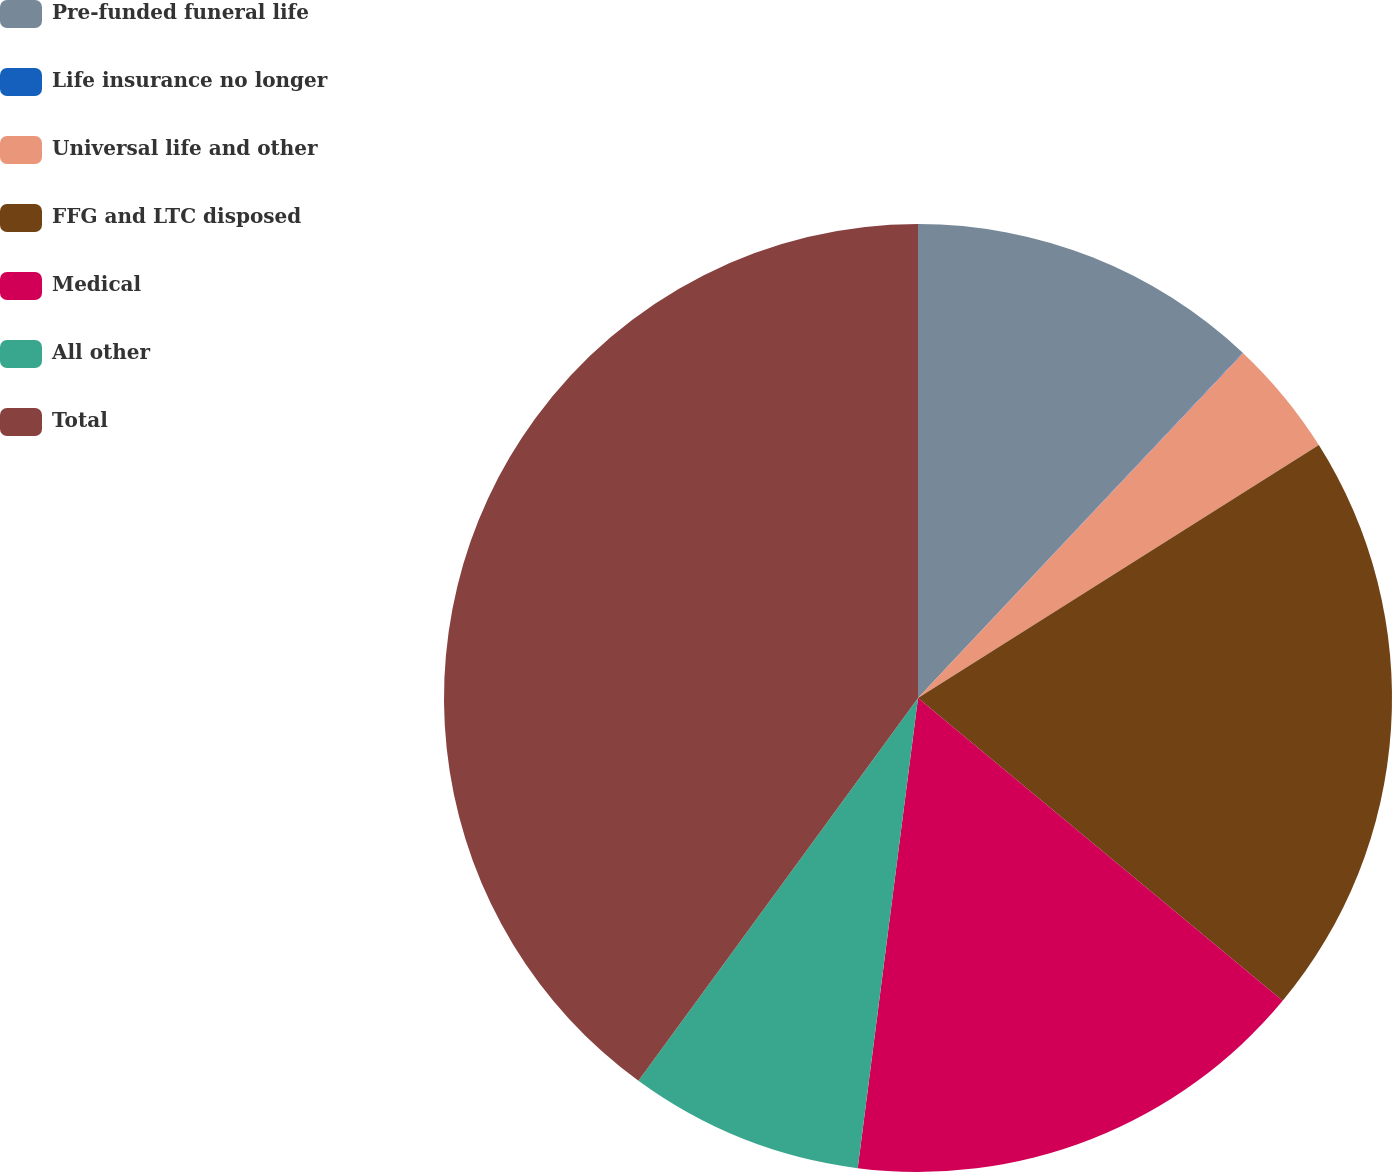Convert chart to OTSL. <chart><loc_0><loc_0><loc_500><loc_500><pie_chart><fcel>Pre-funded funeral life<fcel>Life insurance no longer<fcel>Universal life and other<fcel>FFG and LTC disposed<fcel>Medical<fcel>All other<fcel>Total<nl><fcel>12.0%<fcel>0.02%<fcel>4.02%<fcel>19.99%<fcel>16.0%<fcel>8.01%<fcel>39.96%<nl></chart> 